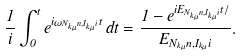Convert formula to latex. <formula><loc_0><loc_0><loc_500><loc_500>\frac { 1 } { i } \int ^ { t } _ { 0 } e ^ { i \omega _ { N _ { k \mu } n , I _ { k \mu } i } t } \, d t = \frac { 1 - e ^ { i E _ { N _ { k \mu } n , I _ { k \mu } i } t / } } { E _ { N _ { k \mu } n , I _ { k \mu } i } } .</formula> 